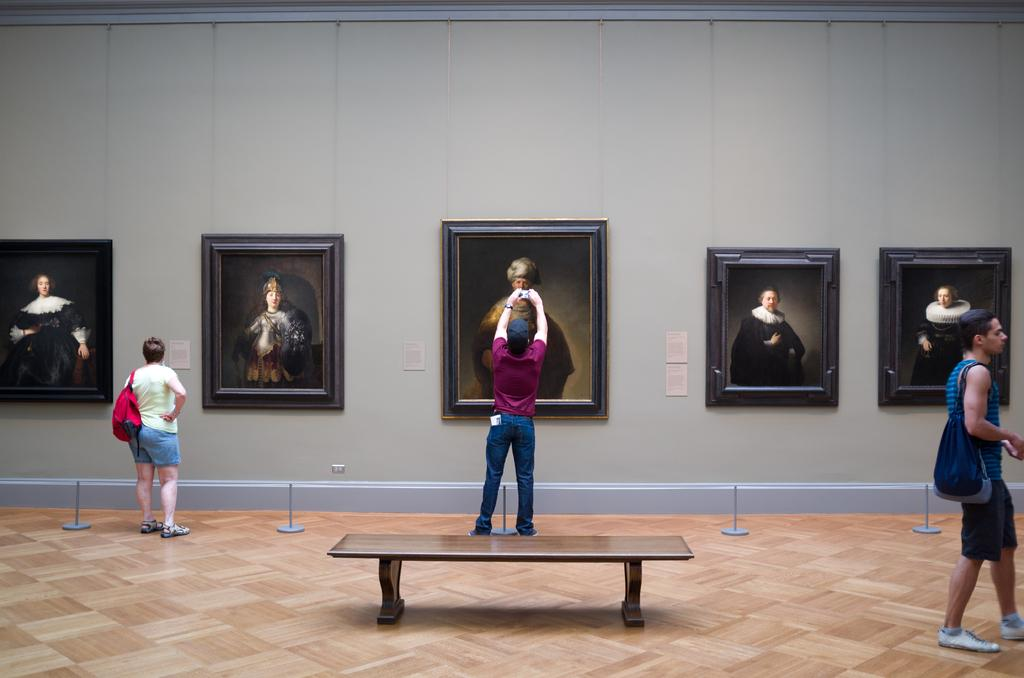Who or what can be seen in the image? There are people in the image. What is on the wall in the image? There are frames on the wall. What piece of furniture is present in the image? There is a table in the image. What advice can be seen being given in the image? There is no indication of advice being given in the image; it only shows people, frames on the wall, and a table. 